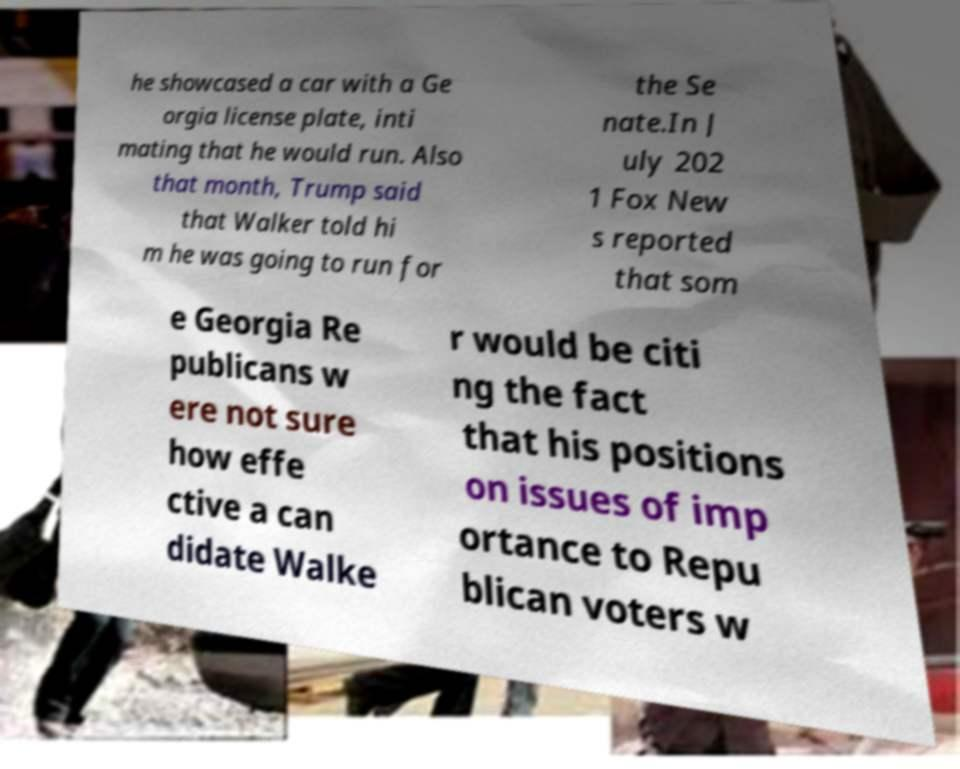There's text embedded in this image that I need extracted. Can you transcribe it verbatim? he showcased a car with a Ge orgia license plate, inti mating that he would run. Also that month, Trump said that Walker told hi m he was going to run for the Se nate.In J uly 202 1 Fox New s reported that som e Georgia Re publicans w ere not sure how effe ctive a can didate Walke r would be citi ng the fact that his positions on issues of imp ortance to Repu blican voters w 